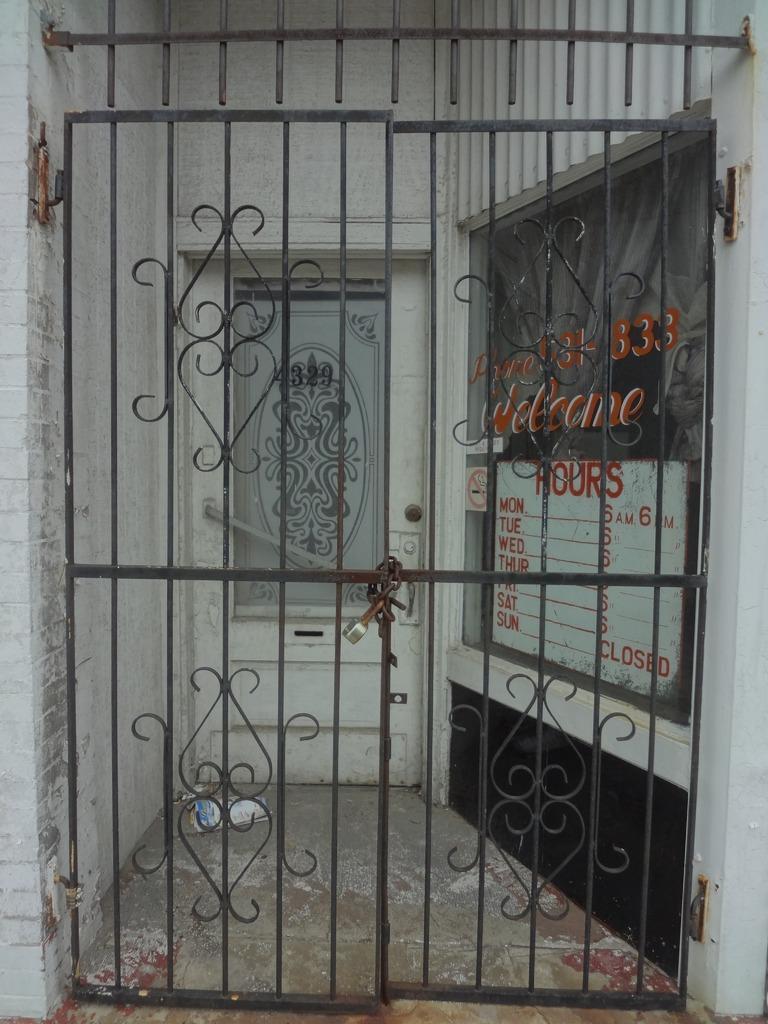Can you describe this image briefly? In this picture it looks like the entrance of a place with the gate locked. 